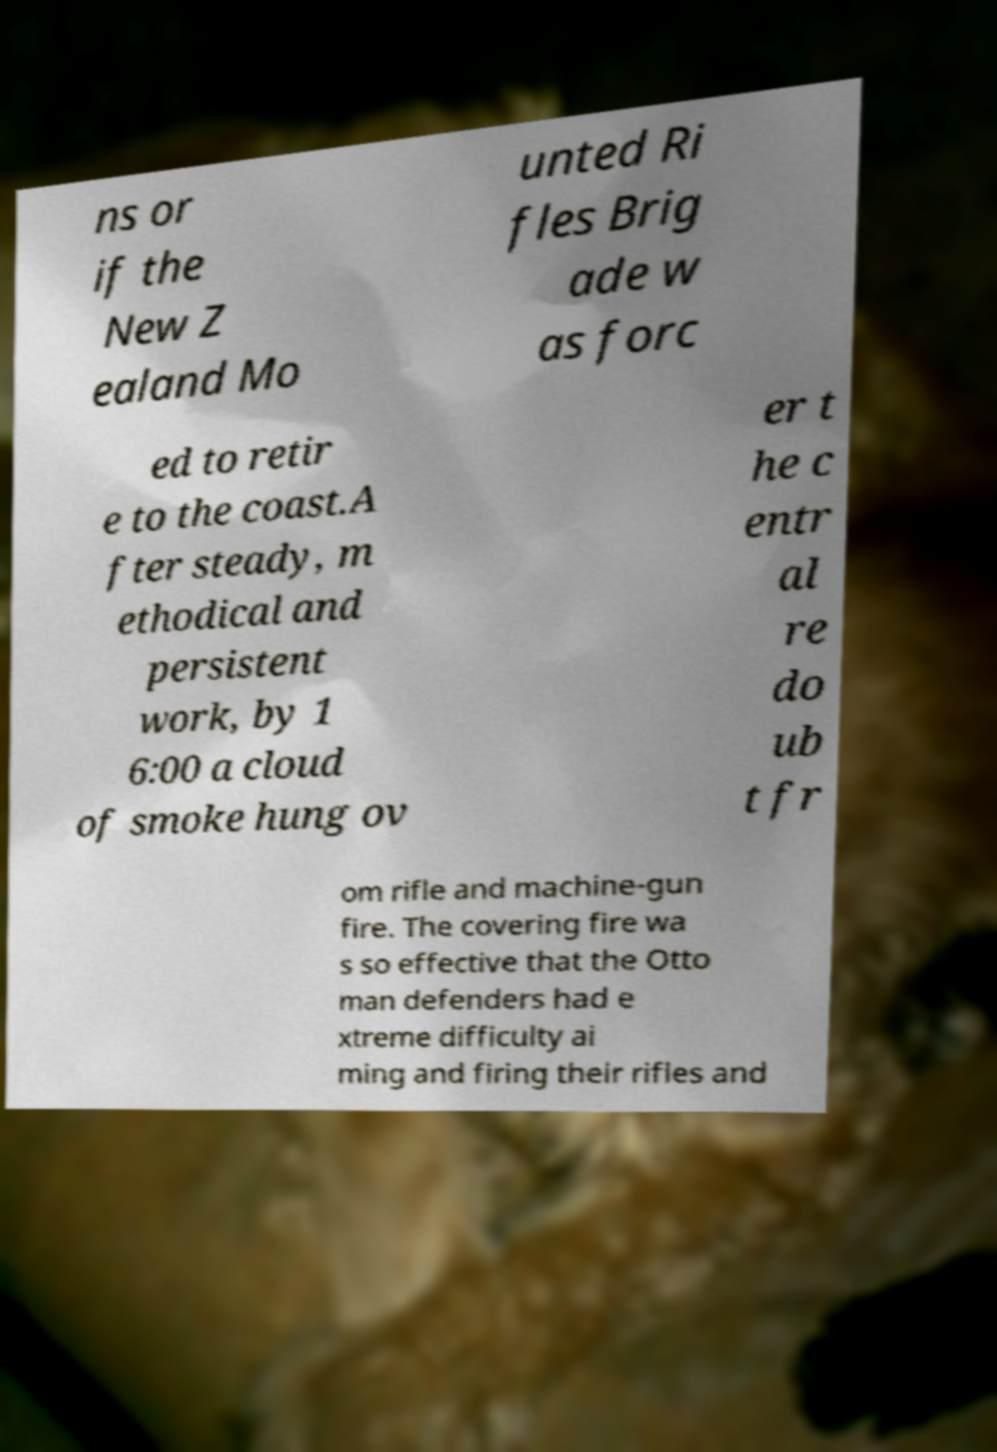Can you accurately transcribe the text from the provided image for me? ns or if the New Z ealand Mo unted Ri fles Brig ade w as forc ed to retir e to the coast.A fter steady, m ethodical and persistent work, by 1 6:00 a cloud of smoke hung ov er t he c entr al re do ub t fr om rifle and machine-gun fire. The covering fire wa s so effective that the Otto man defenders had e xtreme difficulty ai ming and firing their rifles and 